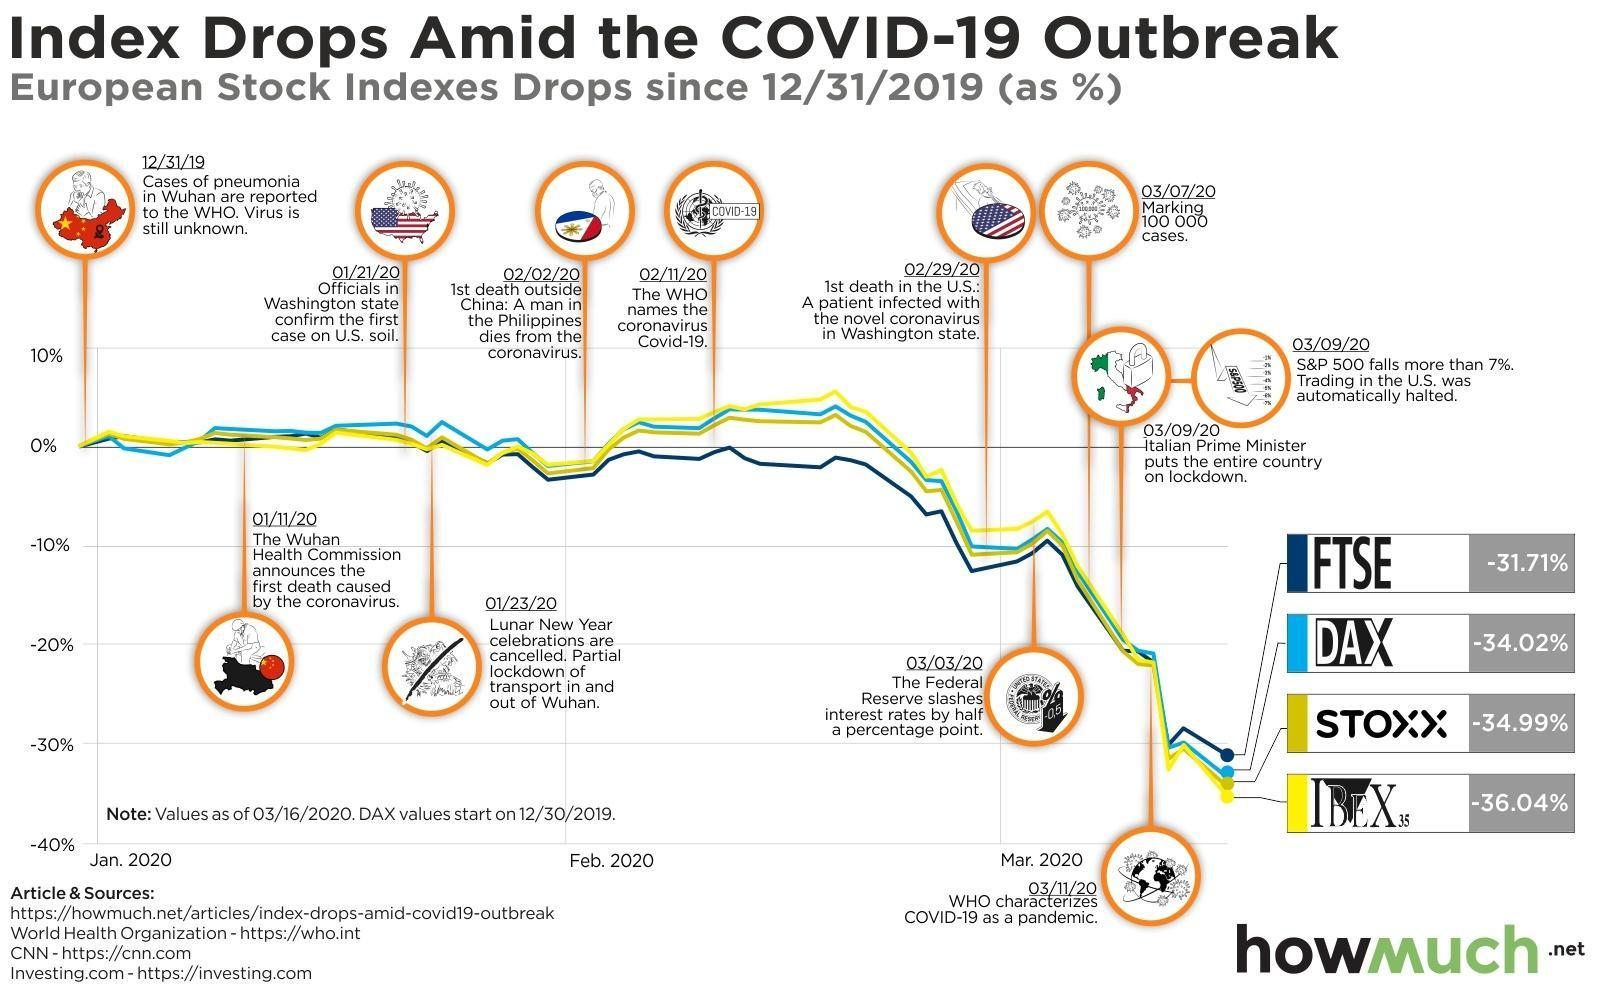When was the first death caused by coronavirus announced in China
Answer the question with a short phrase. 01/11/20 What is represented by the green line STOXX When did the first death outside China due to coronavirus occur 02/02/20 what is represented by the yellow line IBEX What event marks 02/11/20 The WHO names the coronavirus Covid-19 What is written beside the logo of WHO COVID-19 When did Italy go under lockdown 03/09/20 